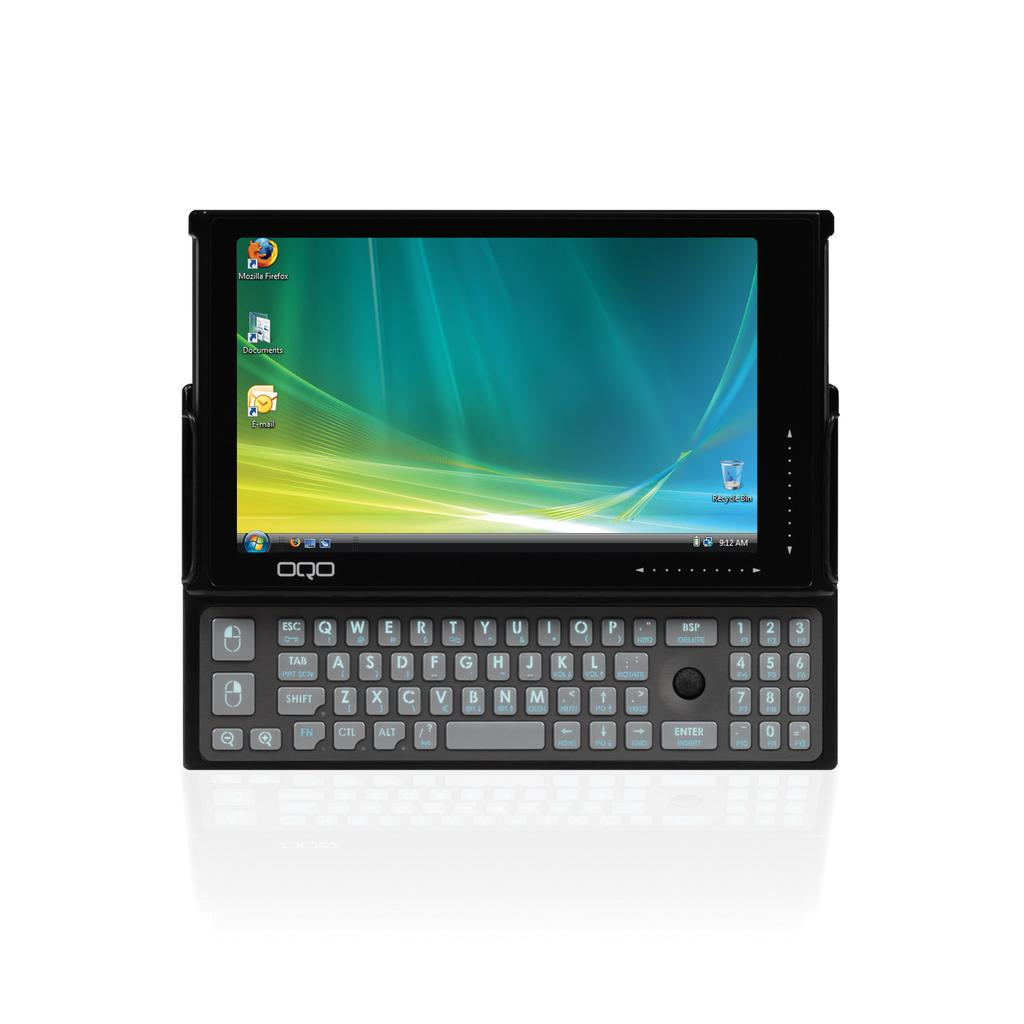<image>
Present a compact description of the photo's key features. An electronic device has Mozilla Firefox on its home screen. 